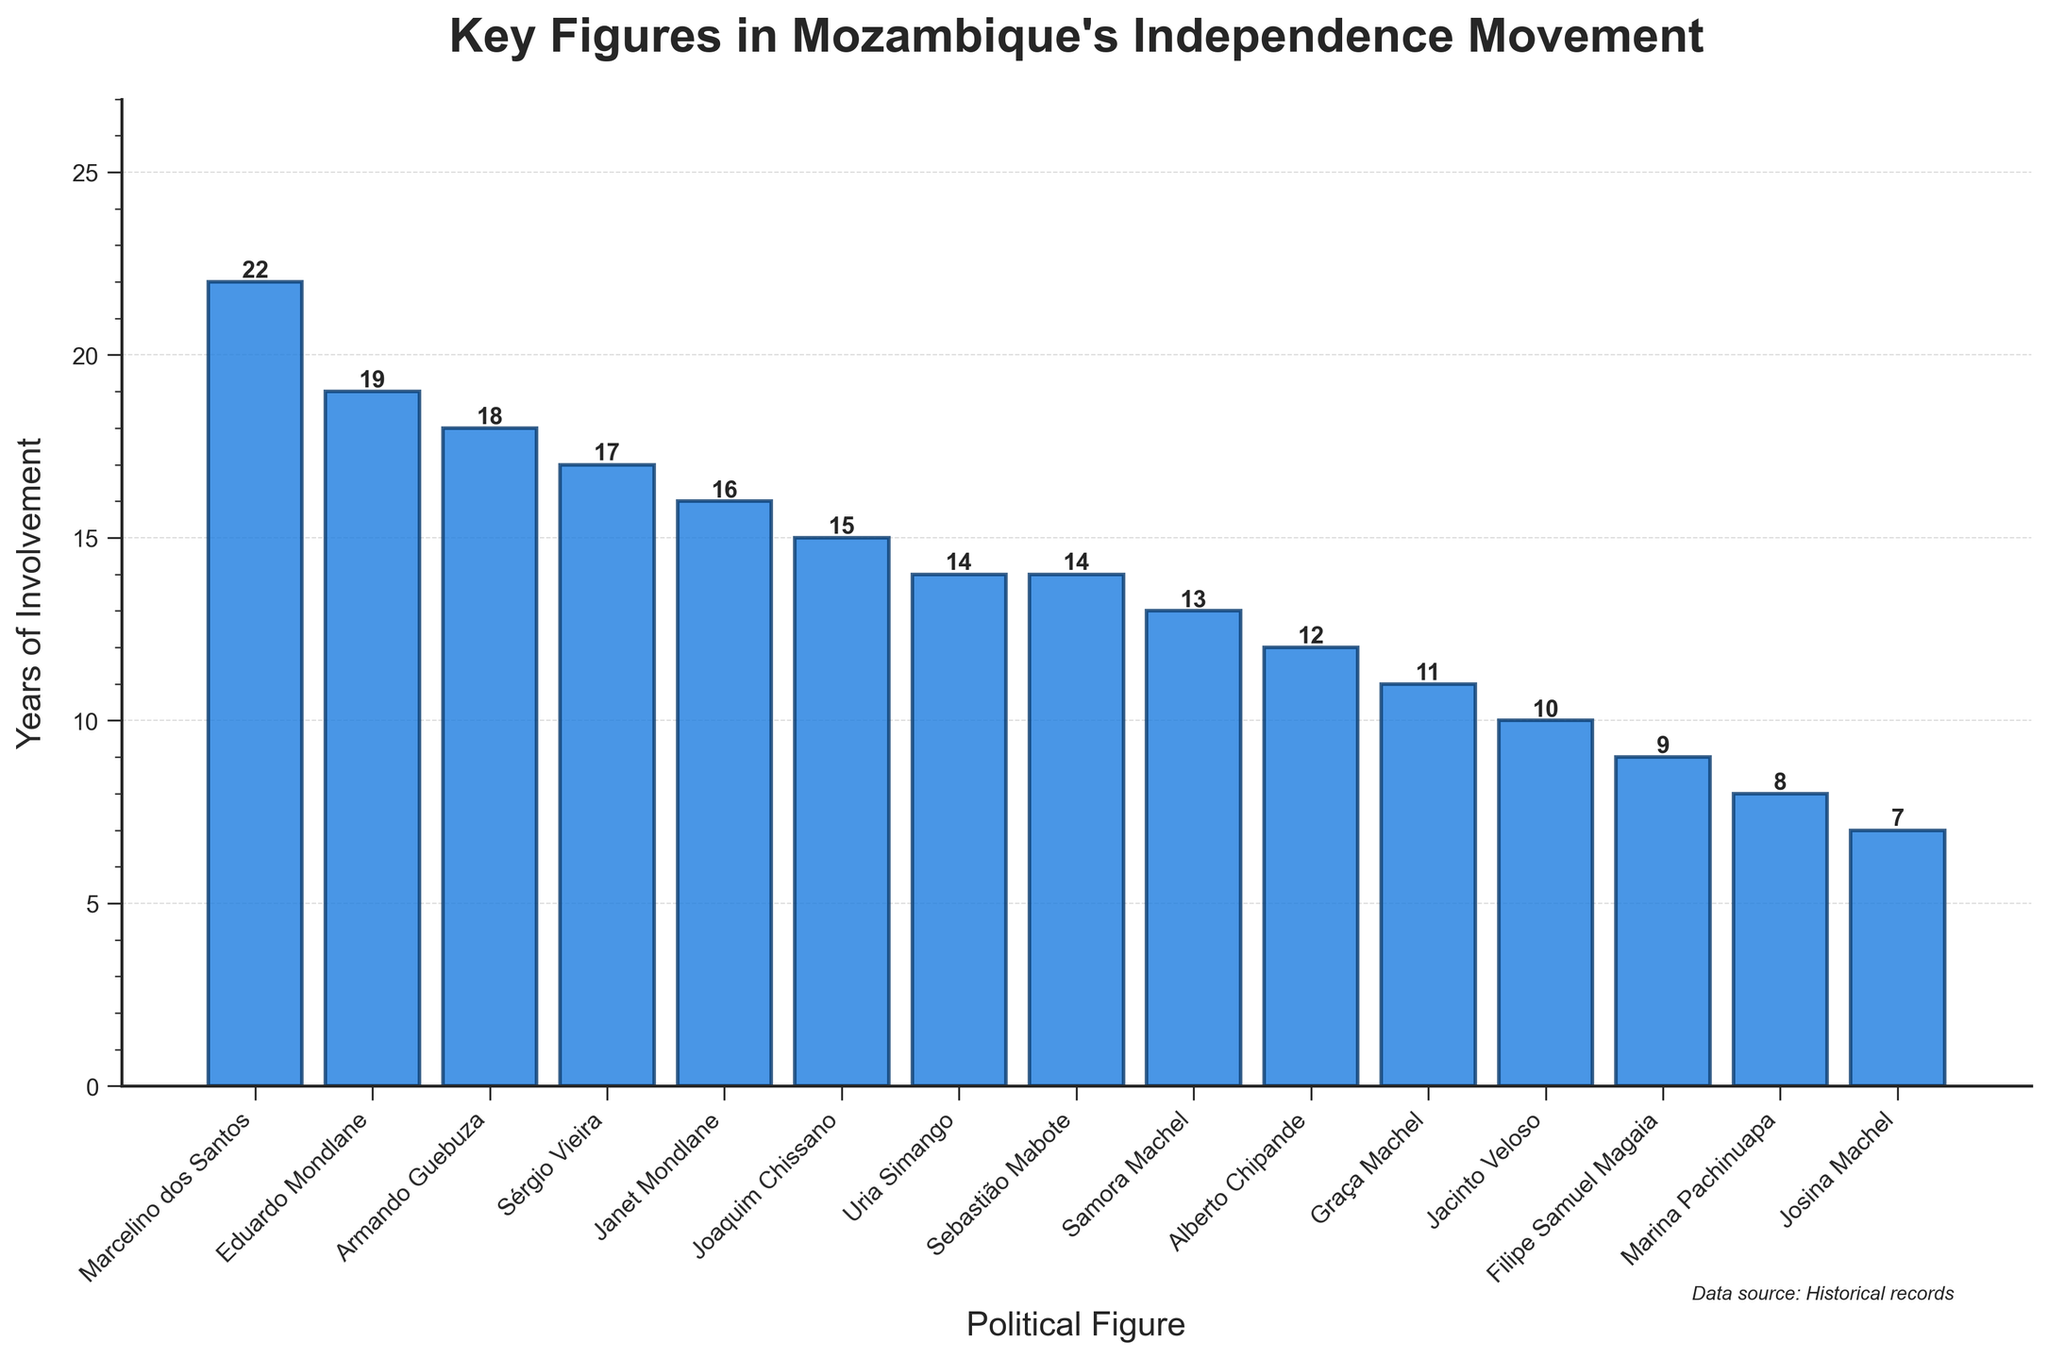Which political figure was involved for the longest period of time in Mozambique's independence movement? Marcelino dos Santos is the political figure with the longest period of involvement. This can easily be determined by looking at the bar chart where his bar is the tallest among all the figures.
Answer: Marcelino dos Santos Which political figure was involved for the shortest period of time in Mozambique's independence movement? Josina Machel has the shortest period of involvement. On the bar chart, her bar is the shortest.
Answer: Josina Machel How many political figures were involved for more than 15 years? To find out, we identify the number of bars exceeding the 15-year mark. The corresponding figures include Marcelino dos Santos, Eduardo Mondlane, Joaquin Chissano, Janet Mondlane, Sérgio Vieira, and Armando Guebuza. Counting them gives us six figures.
Answer: Six What is the total combined years of involvement for Eduardo Mondlane and Samora Machel? Adding the years of involvement of Eduardo Mondlane (19 years) and Samora Machel (13 years) results in 32 years.
Answer: 32 years Is Joaquim Chissano's involvement longer than Uria Simango's? Joaquim Chissano’s involvement is 15 years, while Uria Simango’s is 14 years. Therefore, Joaquim Chissano’s involvement is indeed longer.
Answer: Yes How many political figures have an equal or greater period of involvement than Sérgio Vieira? Sérgio Vieira was involved for 17 years. We count the bars that reach or exceed 17 years: Marcelino dos Santos (22), Eduardo Mondlane (19), Janet Mondlane (16), and Armando Guebuza (18). Including Sérgio Vieira himself gives five figures.
Answer: Five What is the difference in the years of involvement between the two Josinas (Machel and Janet)? Josina Machel was involved for 7 years, and Janet Mondlane was involved for 16 years. The difference is 16 - 7 = 9 years.
Answer: 9 years Which political figure's bar is colored blue and has involvement closest to 10 years? Jacinto Veloso's bar is colored blue and has 10 years of involvement, which is exactly 10 years.
Answer: Jacinto Veloso Between Alberto Chipande and Graça Machel, who had a longer involvement in the movement and by how many years? Alberto Chipande was involved for 12 years and Graça Machel was involved for 11 years. The difference is 12 - 11 = 1 year.
Answer: Alberto Chipande by 1 year 